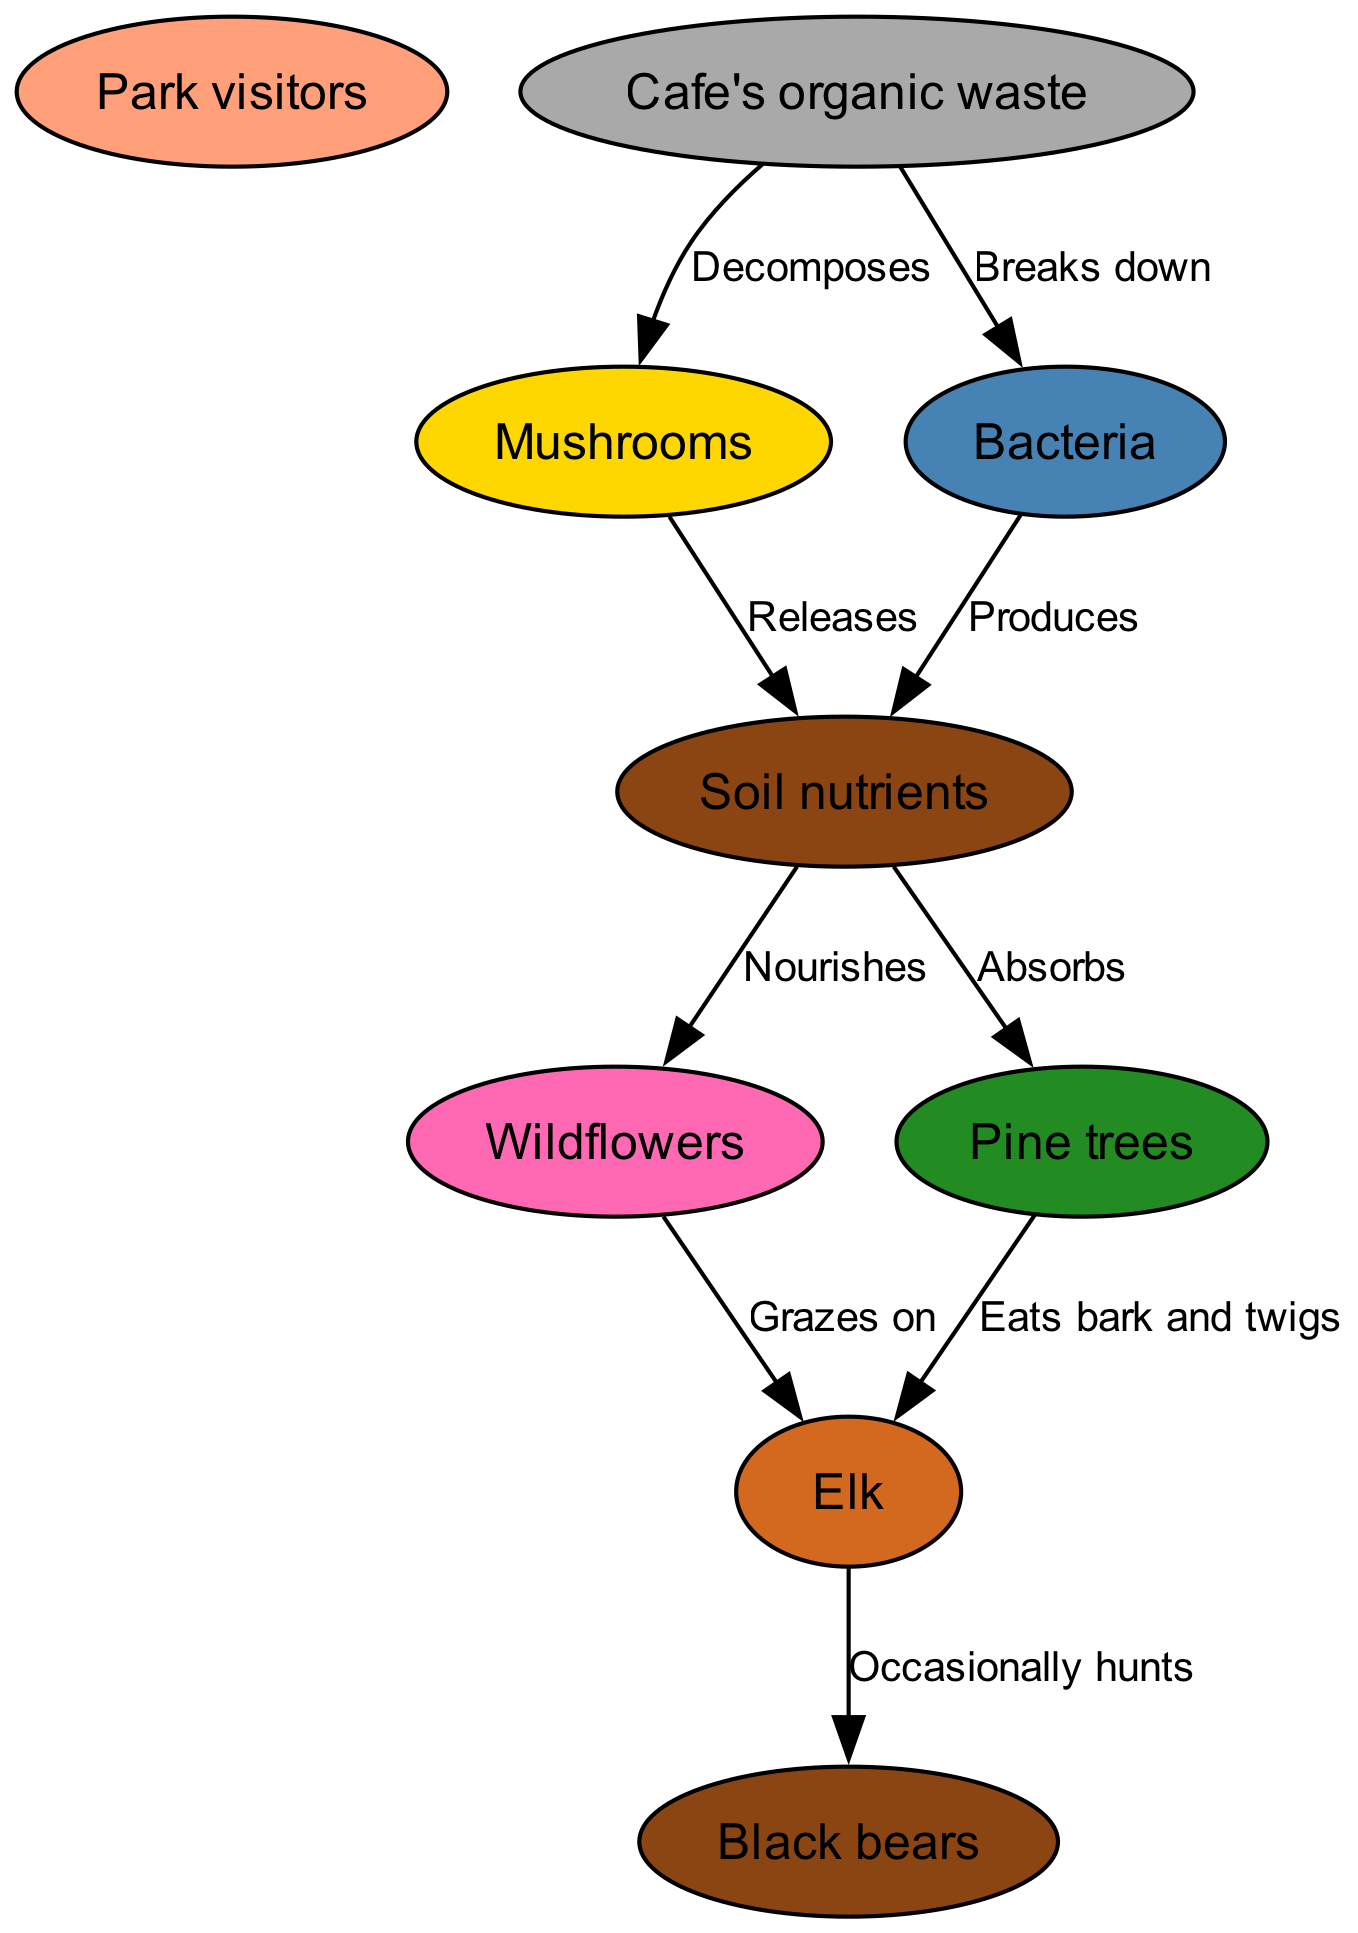What organisms are involved in the nutrient cycle? The diagram lists the organisms involved, which include Park visitors, Black bears, Elk, Wildflowers, Pine trees, Mushrooms, and Bacteria. These are all identified as nodes in the ecosystem.
Answer: Park visitors, Black bears, Elk, Wildflowers, Pine trees, Mushrooms, Bacteria Who decomposes the cafe's organic waste? The relationships in the diagram indicate that Mushrooms and Bacteria are the organisms that decompose the cafe's organic waste. The edges from "Cafe's organic waste" lead to both of these organisms with corresponding labels.
Answer: Mushrooms, Bacteria What does the fungi release into the soil? The diagram specifies that the mushrooms release soil nutrients. This is directly mentioned in the relationship connecting Mushrooms to Soil nutrients in the diagram.
Answer: Soil nutrients How many edges are connected to the Elk? By reviewing the relationships, we see that Elk has two outgoing connections: one to Black bears (as prey) and another to both Pine trees and Wildflowers (as food sources). Therefore, the total number of edges connected to Elk is three.
Answer: 3 What is the role of bacteria in the nutrient cycle? According to the diagram, Bacteria breaks down the cafe's organic waste and produces soil nutrients. This means its role is twofold: aiding in waste decomposition and contributing to soil nutrient production.
Answer: Breaks down organic waste and produces soil nutrients Which organism is at the top of the food chain? By evaluating the relationships, Black bears are indicated as the top predator, as they occasionally hunt Elk, which means they are at a higher trophic level in this food chain context.
Answer: Black bears How do pine trees receive nutrients? The diagram illustrates that Pine trees absorb soil nutrients, which they obtain through the connections marked from Soil nutrients to Pine trees. This depicts the flow of nutrients back into the plant.
Answer: Absorbs What is the primary source of soil nutrients? The relationships indicate that both Mushrooms and Bacteria produce soil nutrients, meaning they are the primary contributors to this aspect of the ecosystem.
Answer: Mushrooms, Bacteria What animal occasionally hunts Elk? The relationship labeled "Occasionally hunts" directly indicates that Black bears are the animals that occasionally hunt Elk, showcasing this predation within the ecosystem's dynamics.
Answer: Black bears 